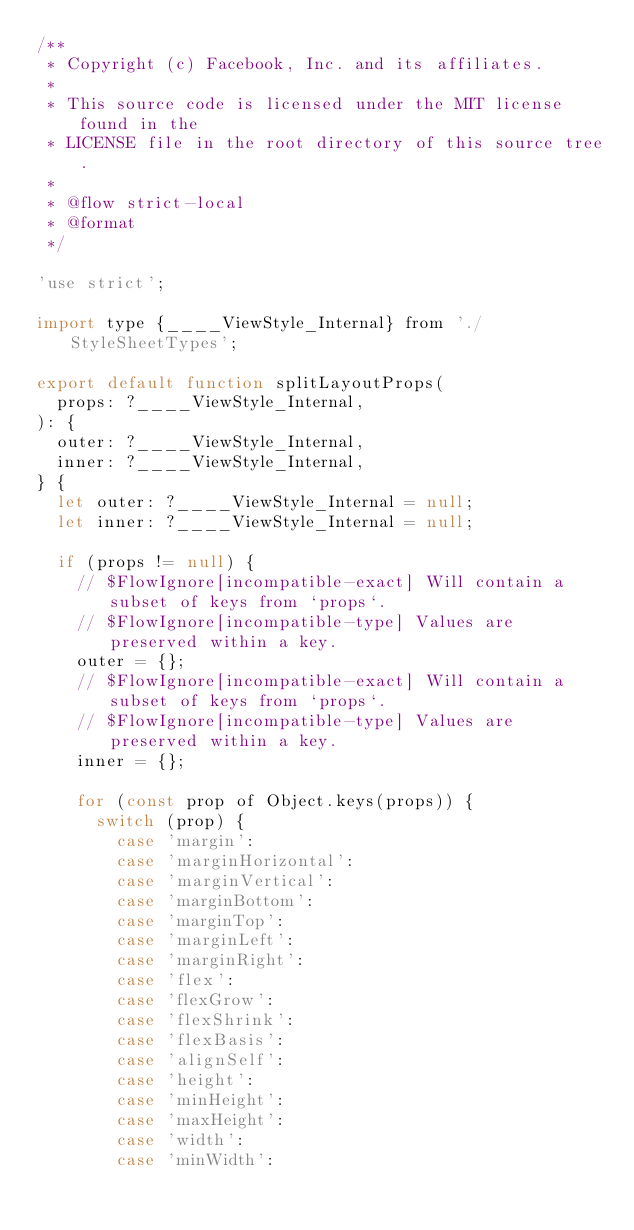<code> <loc_0><loc_0><loc_500><loc_500><_JavaScript_>/**
 * Copyright (c) Facebook, Inc. and its affiliates.
 *
 * This source code is licensed under the MIT license found in the
 * LICENSE file in the root directory of this source tree.
 *
 * @flow strict-local
 * @format
 */

'use strict';

import type {____ViewStyle_Internal} from './StyleSheetTypes';

export default function splitLayoutProps(
  props: ?____ViewStyle_Internal,
): {
  outer: ?____ViewStyle_Internal,
  inner: ?____ViewStyle_Internal,
} {
  let outer: ?____ViewStyle_Internal = null;
  let inner: ?____ViewStyle_Internal = null;

  if (props != null) {
    // $FlowIgnore[incompatible-exact] Will contain a subset of keys from `props`.
    // $FlowIgnore[incompatible-type] Values are preserved within a key.
    outer = {};
    // $FlowIgnore[incompatible-exact] Will contain a subset of keys from `props`.
    // $FlowIgnore[incompatible-type] Values are preserved within a key.
    inner = {};

    for (const prop of Object.keys(props)) {
      switch (prop) {
        case 'margin':
        case 'marginHorizontal':
        case 'marginVertical':
        case 'marginBottom':
        case 'marginTop':
        case 'marginLeft':
        case 'marginRight':
        case 'flex':
        case 'flexGrow':
        case 'flexShrink':
        case 'flexBasis':
        case 'alignSelf':
        case 'height':
        case 'minHeight':
        case 'maxHeight':
        case 'width':
        case 'minWidth':</code> 